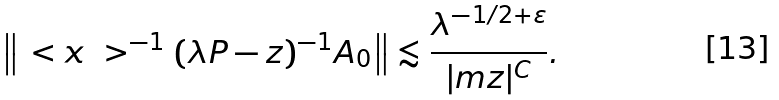<formula> <loc_0><loc_0><loc_500><loc_500>\left \| \ < x \ > ^ { - 1 } ( \lambda P - z ) ^ { - 1 } A _ { 0 } \right \| \lesssim \frac { \lambda ^ { - 1 / 2 + \varepsilon } } { | \i m z | ^ { C } } .</formula> 